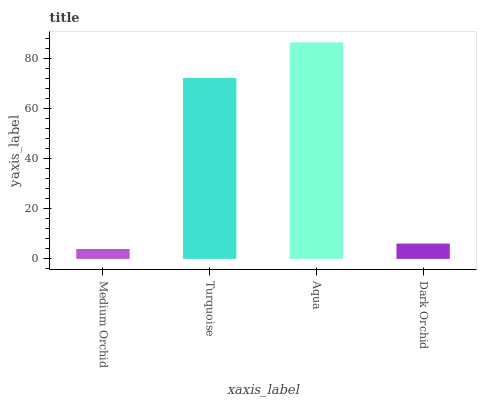Is Medium Orchid the minimum?
Answer yes or no. Yes. Is Aqua the maximum?
Answer yes or no. Yes. Is Turquoise the minimum?
Answer yes or no. No. Is Turquoise the maximum?
Answer yes or no. No. Is Turquoise greater than Medium Orchid?
Answer yes or no. Yes. Is Medium Orchid less than Turquoise?
Answer yes or no. Yes. Is Medium Orchid greater than Turquoise?
Answer yes or no. No. Is Turquoise less than Medium Orchid?
Answer yes or no. No. Is Turquoise the high median?
Answer yes or no. Yes. Is Dark Orchid the low median?
Answer yes or no. Yes. Is Dark Orchid the high median?
Answer yes or no. No. Is Turquoise the low median?
Answer yes or no. No. 